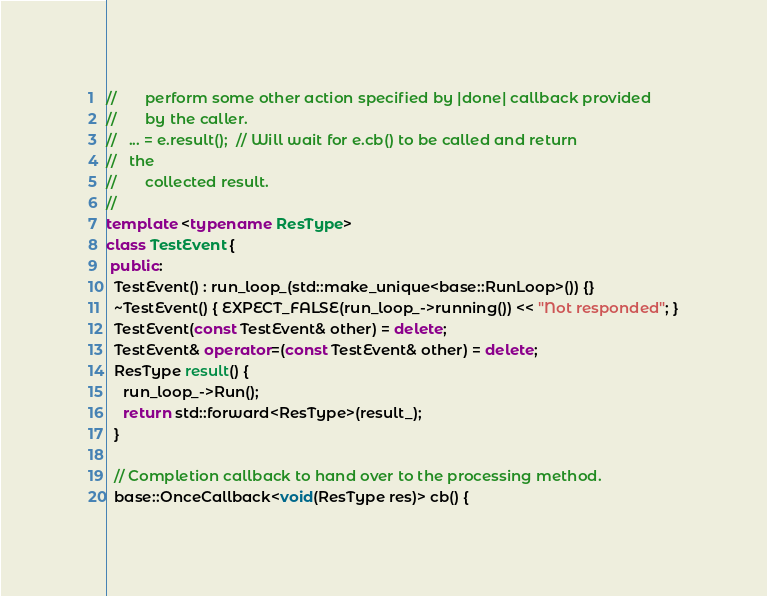Convert code to text. <code><loc_0><loc_0><loc_500><loc_500><_C++_>//       perform some other action specified by |done| callback provided
//       by the caller.
//   ... = e.result();  // Will wait for e.cb() to be called and return
//   the
//       collected result.
//
template <typename ResType>
class TestEvent {
 public:
  TestEvent() : run_loop_(std::make_unique<base::RunLoop>()) {}
  ~TestEvent() { EXPECT_FALSE(run_loop_->running()) << "Not responded"; }
  TestEvent(const TestEvent& other) = delete;
  TestEvent& operator=(const TestEvent& other) = delete;
  ResType result() {
    run_loop_->Run();
    return std::forward<ResType>(result_);
  }

  // Completion callback to hand over to the processing method.
  base::OnceCallback<void(ResType res)> cb() {</code> 